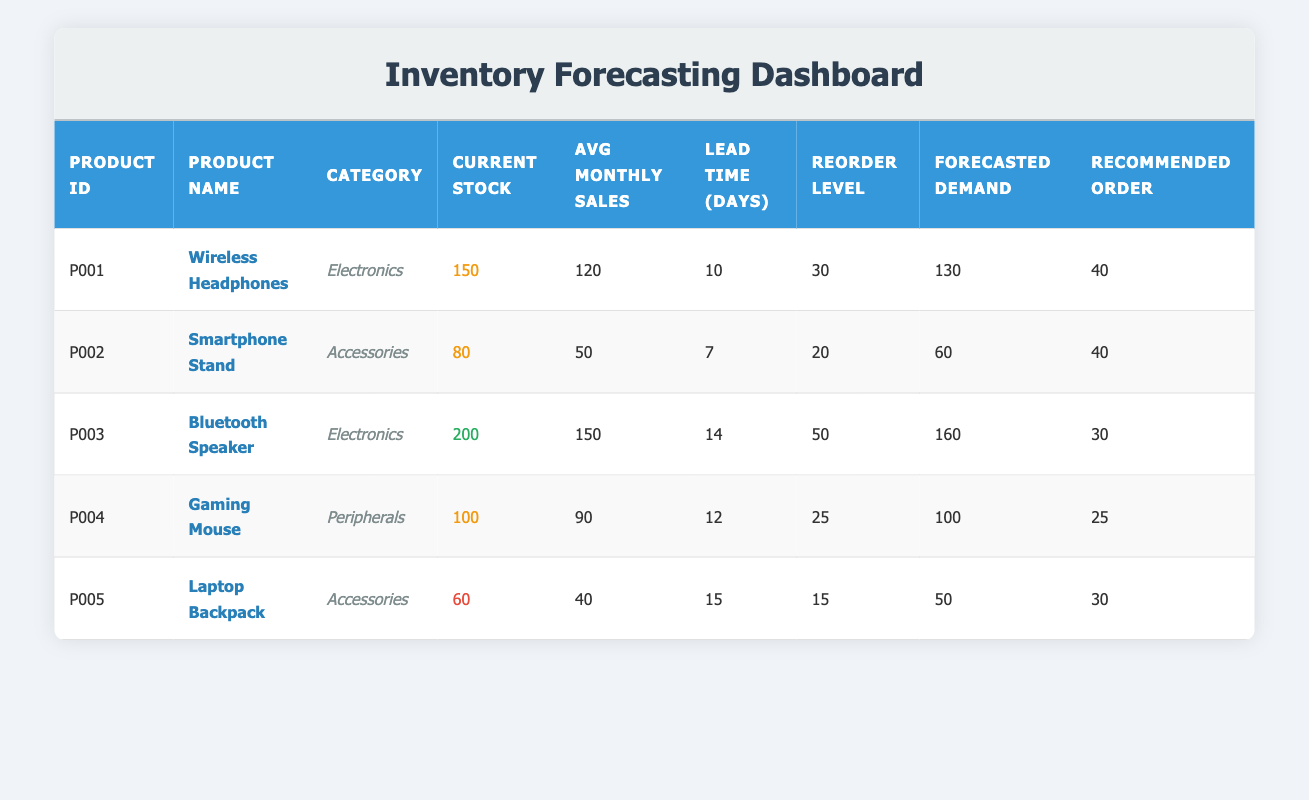What is the current stock of Wireless Headphones? The table shows the row for Wireless Headphones (P001) and provides the current stock as 150 units.
Answer: 150 How many units of the Smartphone Stand are recommended to order? In the row for Smartphone Stand (P002), the recommended order quantity is listed as 40 units.
Answer: 40 Which product has the highest average monthly sales? The average monthly sales figures for each product are compared: Wireless Headphones (120), Smartphone Stand (50), Bluetooth Speaker (150), Gaming Mouse (90), and Laptop Backpack (40). The Bluetooth Speaker has the highest sales at 150.
Answer: Bluetooth Speaker What is the total quantity of products that need to be ordered based on their forecasted demand next month? The recommended order quantities are summed: 40 + 40 + 30 + 25 + 30 = 165 units.
Answer: 165 Is the current stock of the Laptop Backpack above its reorder level? The current stock of Laptop Backpack (60) is compared to its reorder level (15). Since 60 is greater than 15, the answer is yes.
Answer: Yes How many days of lead time does the Bluetooth Speaker have before it can be reordered? The lead time for the Bluetooth Speaker (P003) is explicitly stated in the table as 14 days.
Answer: 14 days Which product category has the lowest current stock? The current stock for each category is reviewed: Electronics (150, 200), Accessories (80, 60), and Peripherals (100). The Laptop Backpack in the Accessories category has the lowest stock at 60 units.
Answer: Accessories What is the difference between the forecasted demand and current stock for the Gaming Mouse? The current stock for Gaming Mouse (100) is compared to the forecasted demand (100). The difference is calculated as 100 - 100 = 0.
Answer: 0 Is the forecasted demand for the Wireless Headphones higher than its average monthly sales? The forecasted demand for Wireless Headphones (130) is compared to its average monthly sales (120). Since 130 is greater than 120, the answer is yes.
Answer: Yes 